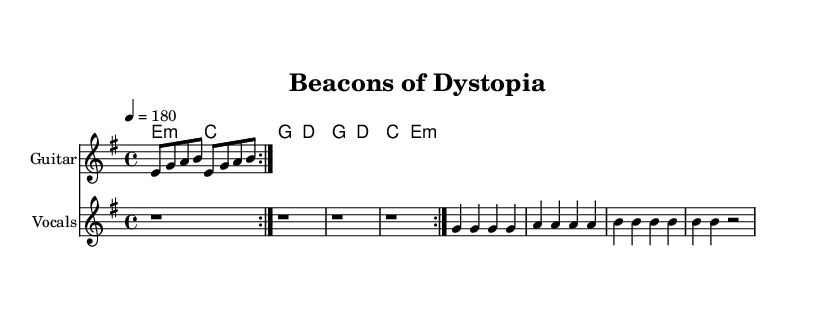What is the key signature of this music? The music is in E minor, which has one sharp (F#). This can be determined by looking at the indicated key in the global section of the code.
Answer: E minor What is the time signature of this music? The time signature is 4/4, as stated in the global section of the code. This indicates there are four beats in each measure.
Answer: 4/4 What tempo marking is used in this music? The tempo marking is quarter note equals 180, which is indicated in the global section of the code. This means the music should be played at a brisk pace.
Answer: 180 How many times is the guitar riff repeated? The guitar riff is repeated twice, as indicated by the repeat volta directive in the guitarRiff section of the code.
Answer: 2 What genre does this music represent? This music represents the punk genre, as suggested by the satirical lyrics and the context of critiquing big tech and surveillance capitalism. Punk music is often associated with rebellion and political commentary.
Answer: Punk What is the main theme of the lyrics? The main theme of the lyrics critiques big tech and surveillance capitalism, which is suggested by phrases like "tracking your moves" and "surveillance capitalism" in the lyrics section.
Answer: Critique of big tech What is the mood of the song based on the tempo and lyrics? The mood of the song is likely energetic and rebellious, as indicated by the fast tempo of 180 and the provocative lyrics criticizing societal norms. This aligns with typical punk themes of defiance and urgency.
Answer: Energetic and rebellious 